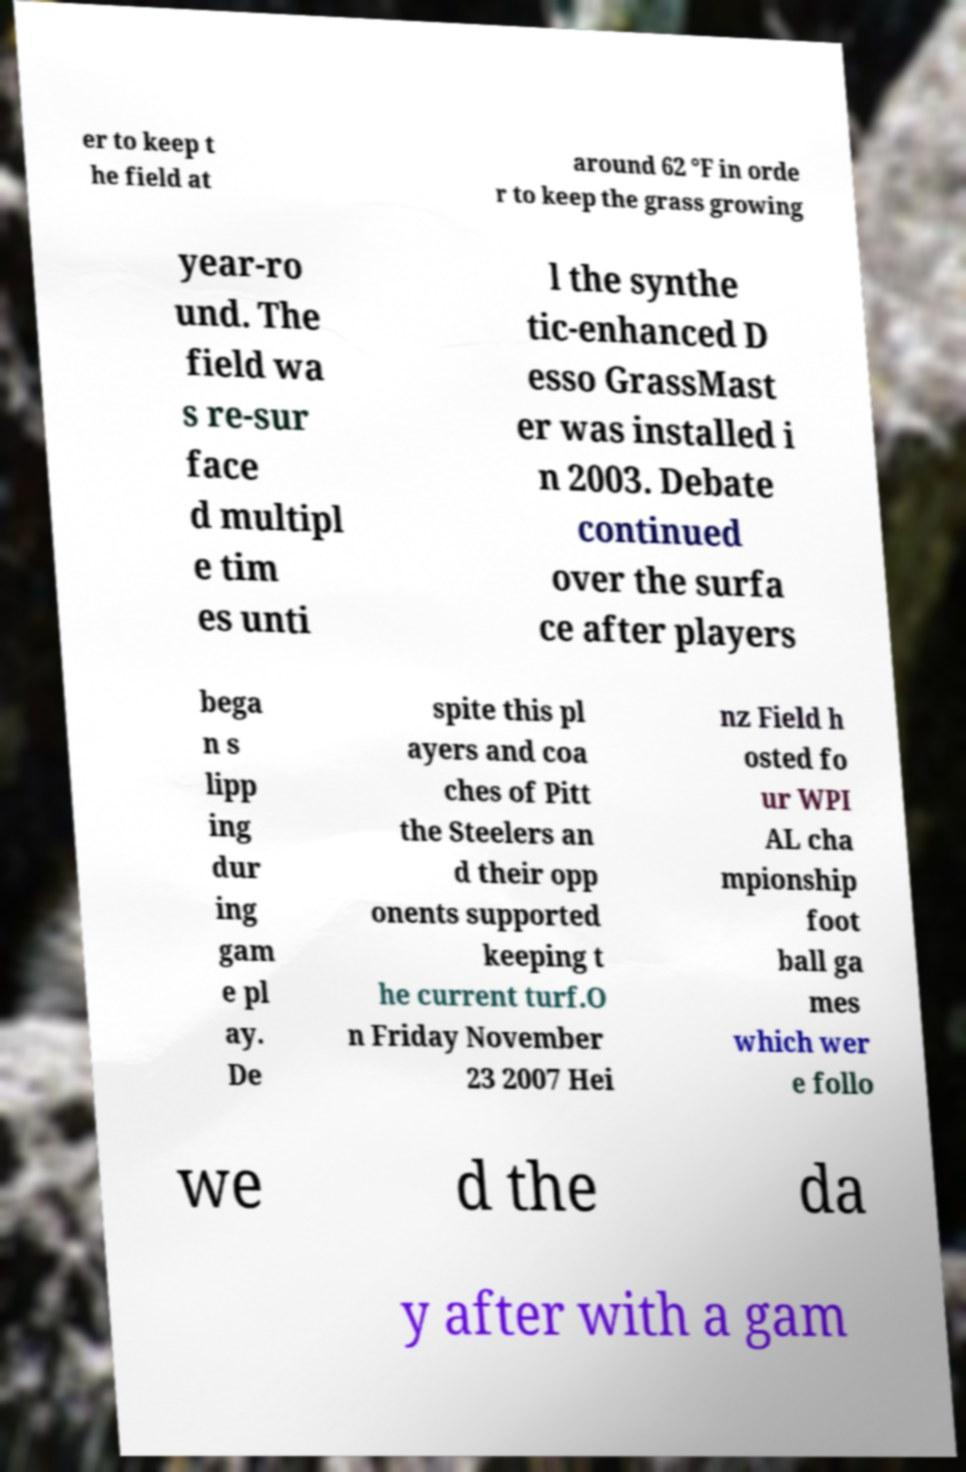What messages or text are displayed in this image? I need them in a readable, typed format. er to keep t he field at around 62 °F in orde r to keep the grass growing year-ro und. The field wa s re-sur face d multipl e tim es unti l the synthe tic-enhanced D esso GrassMast er was installed i n 2003. Debate continued over the surfa ce after players bega n s lipp ing dur ing gam e pl ay. De spite this pl ayers and coa ches of Pitt the Steelers an d their opp onents supported keeping t he current turf.O n Friday November 23 2007 Hei nz Field h osted fo ur WPI AL cha mpionship foot ball ga mes which wer e follo we d the da y after with a gam 